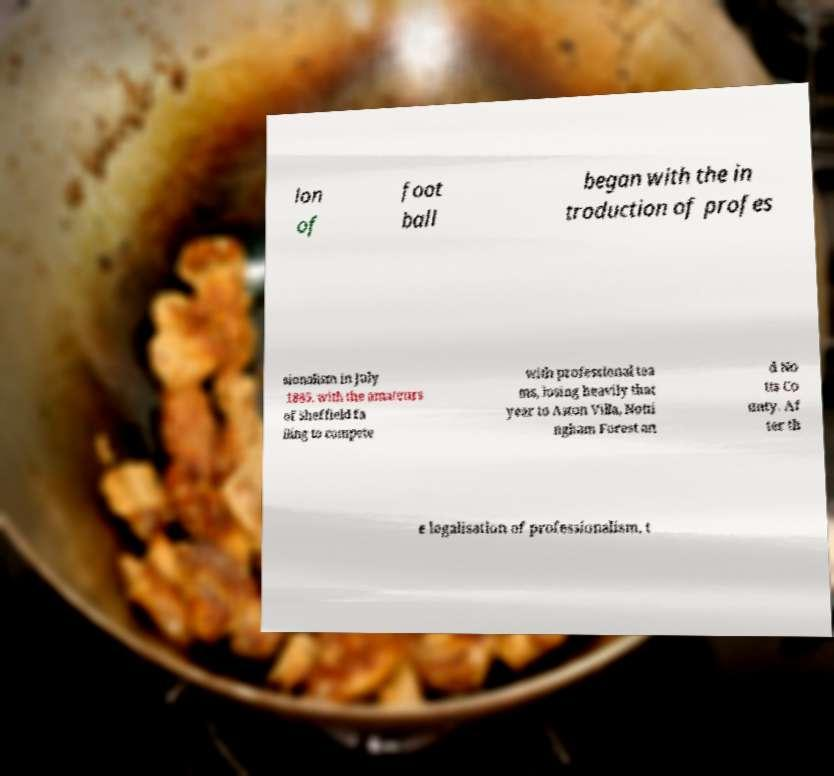What messages or text are displayed in this image? I need them in a readable, typed format. lon of foot ball began with the in troduction of profes sionalism in July 1885, with the amateurs of Sheffield fa iling to compete with professional tea ms, losing heavily that year to Aston Villa, Notti ngham Forest an d No tts Co unty. Af ter th e legalisation of professionalism, t 